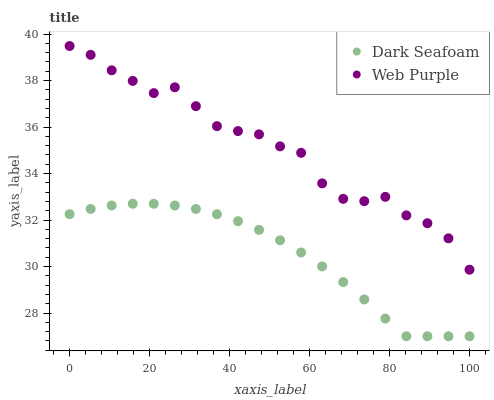Does Dark Seafoam have the minimum area under the curve?
Answer yes or no. Yes. Does Web Purple have the maximum area under the curve?
Answer yes or no. Yes. Does Web Purple have the minimum area under the curve?
Answer yes or no. No. Is Dark Seafoam the smoothest?
Answer yes or no. Yes. Is Web Purple the roughest?
Answer yes or no. Yes. Is Web Purple the smoothest?
Answer yes or no. No. Does Dark Seafoam have the lowest value?
Answer yes or no. Yes. Does Web Purple have the lowest value?
Answer yes or no. No. Does Web Purple have the highest value?
Answer yes or no. Yes. Is Dark Seafoam less than Web Purple?
Answer yes or no. Yes. Is Web Purple greater than Dark Seafoam?
Answer yes or no. Yes. Does Dark Seafoam intersect Web Purple?
Answer yes or no. No. 